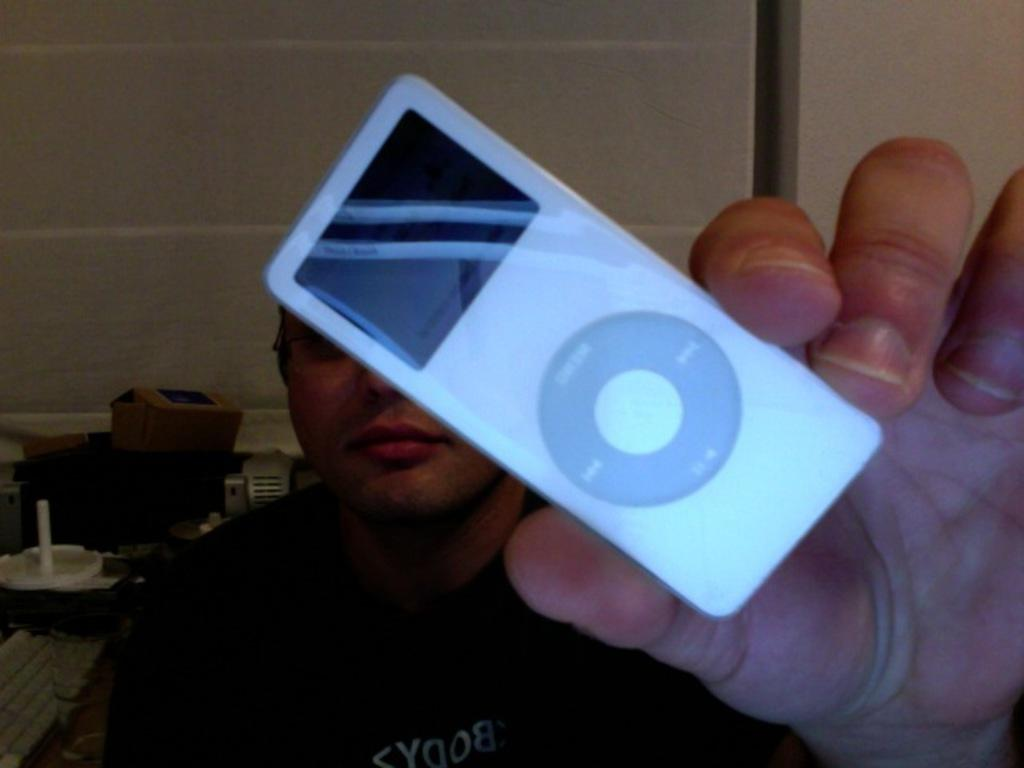What is the main subject in the foreground of the image? There is a person in the foreground of the image. What is the person holding in the image? The person is holding an iPod. What can be seen in the background of the image? There is a wall and a cardboard box in the background of the image. What else is present in the background of the image? There are objects on a table in the background of the image. How does the person distribute the ball in the image? There is no ball present in the image, so the person cannot distribute it. What type of hearing aid is the person using in the image? There is no mention of a hearing aid in the image, so it cannot be determined if the person is using one. 